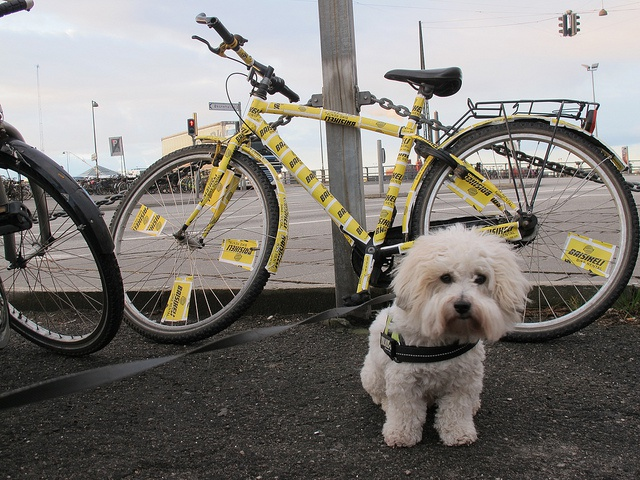Describe the objects in this image and their specific colors. I can see bicycle in lightgray, darkgray, black, and gray tones, dog in lightgray, darkgray, gray, and black tones, bicycle in lightgray, black, darkgray, and gray tones, traffic light in lightgray, gray, darkgray, and black tones, and traffic light in lightgray, darkgray, and gray tones in this image. 